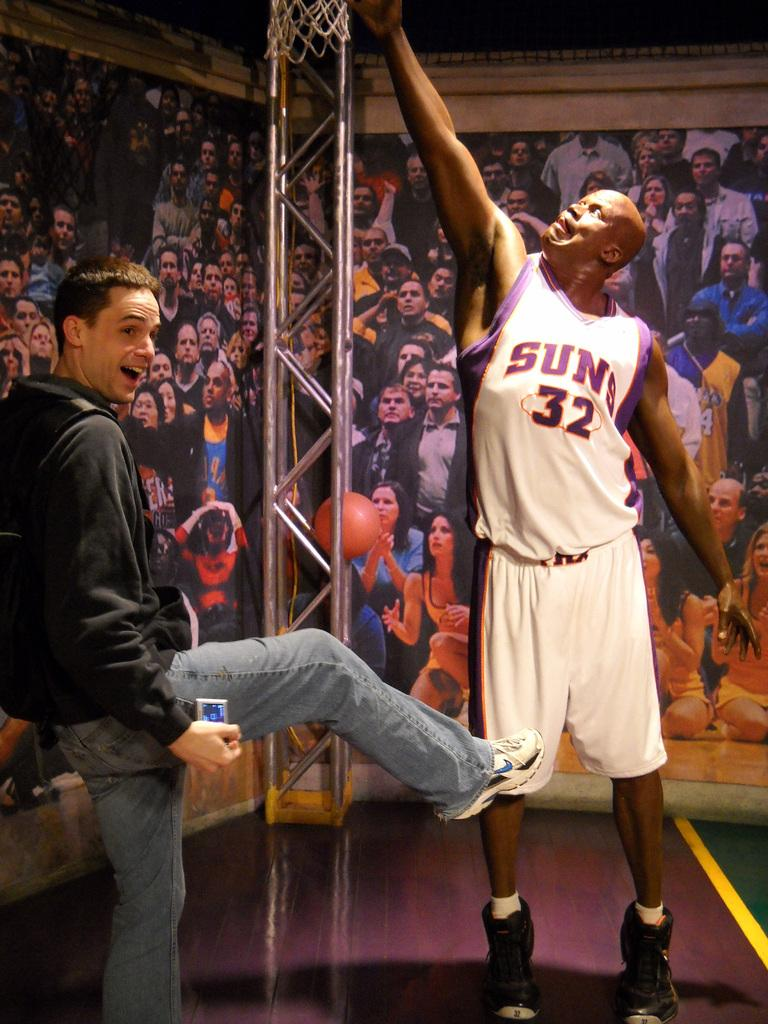<image>
Share a concise interpretation of the image provided. A man poses with a statue of Suns player number 32. 